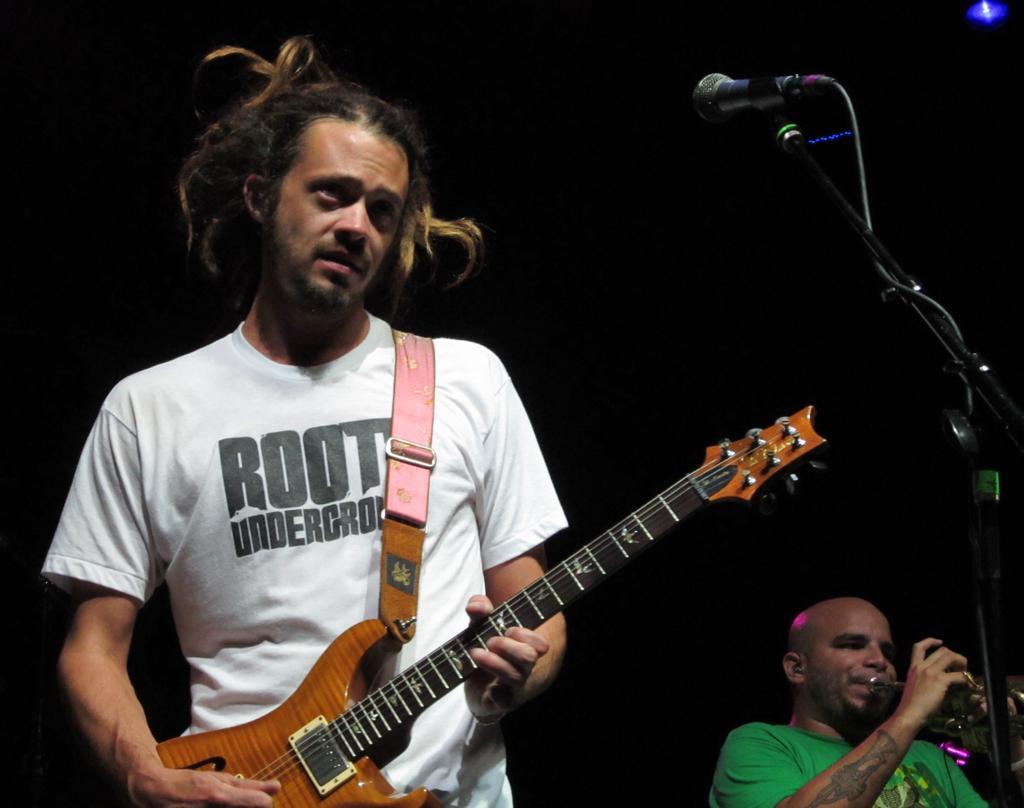Can you describe this image briefly? In this picture there are two musicians, the person on the left side is wearing a white t-shirt and playing a Guitar and the person on the right side is playing a Trumpet and there is a tattoo designed on his hand and there is a microphone placed with the help of a stand. 